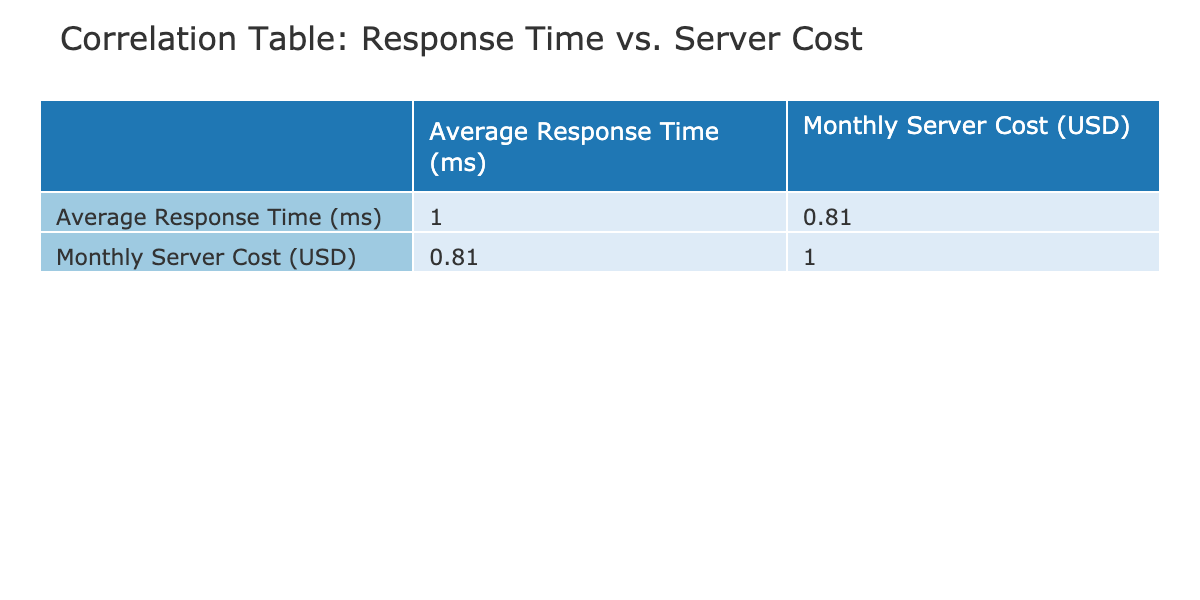What is the average response time for Edge Computing (Local Node)? The table shows the Average Response Time for Edge Computing (Local Node) as 80 ms.
Answer: 80 ms What is the monthly server cost for Traditional Data Center? The table indicates the Monthly Server Cost for Traditional Data Center as 8000 USD.
Answer: 8000 USD Which setup has the lowest monthly server cost? The lowest monthly server cost is found in Edge Computing (Local Node) at 3000 USD.
Answer: Edge Computing (Local Node) Is the average response time for Edge Computing (Private Edge) lower than that of Traditional Hybrid? The average response time for Edge Computing (Private Edge) is 70 ms and for Traditional Hybrid it's 110 ms, so yes, it is lower.
Answer: Yes What is the correlation coefficient between average response time and monthly server cost? The correlation coefficient is not explicitly listed in the table, but by checking the correlation values, it can be inferred that costs likely correlate negatively with response times.
Answer: Not directly available What is the difference in response time between the fastest setup and the slowest setup? The fastest response time is 70 ms (Edge Computing - Private Edge) and the slowest is 160 ms (Traditional Data Center). The difference is 160 - 70 = 90 ms.
Answer: 90 ms How much more does Traditional On-Premise cost compared to Edge Computing (Public Edge)? Traditional On-Premise costs 7000 USD and Edge Computing (Public Edge) costs 4000 USD, so 7000 - 4000 = 3000 USD more.
Answer: 3000 USD Are Edge Computing setups generally cheaper than Traditional setups? By comparing costs, most Edge Computing setups (Local Node, Regional Node, Private Edge, Public Edge) are cheaper than the Traditional setups.
Answer: Yes What is the average monthly server cost of all Edge Computing setups? The setups are: Local Node (3000), Regional Node (4500), Private Edge (3500), and Public Edge (4000). The average is (3000 + 4500 + 3500 + 4000) / 4 = 3750 USD.
Answer: 3750 USD 